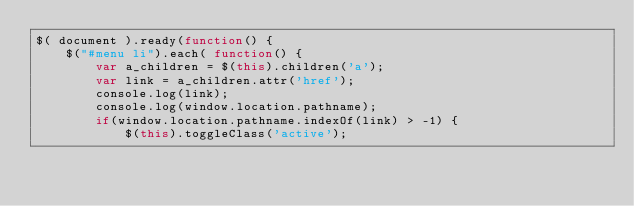<code> <loc_0><loc_0><loc_500><loc_500><_JavaScript_>$( document ).ready(function() {
    $("#menu li").each( function() {
        var a_children = $(this).children('a');
        var link = a_children.attr('href');
        console.log(link);
        console.log(window.location.pathname);
        if(window.location.pathname.indexOf(link) > -1) {
            $(this).toggleClass('active');</code> 